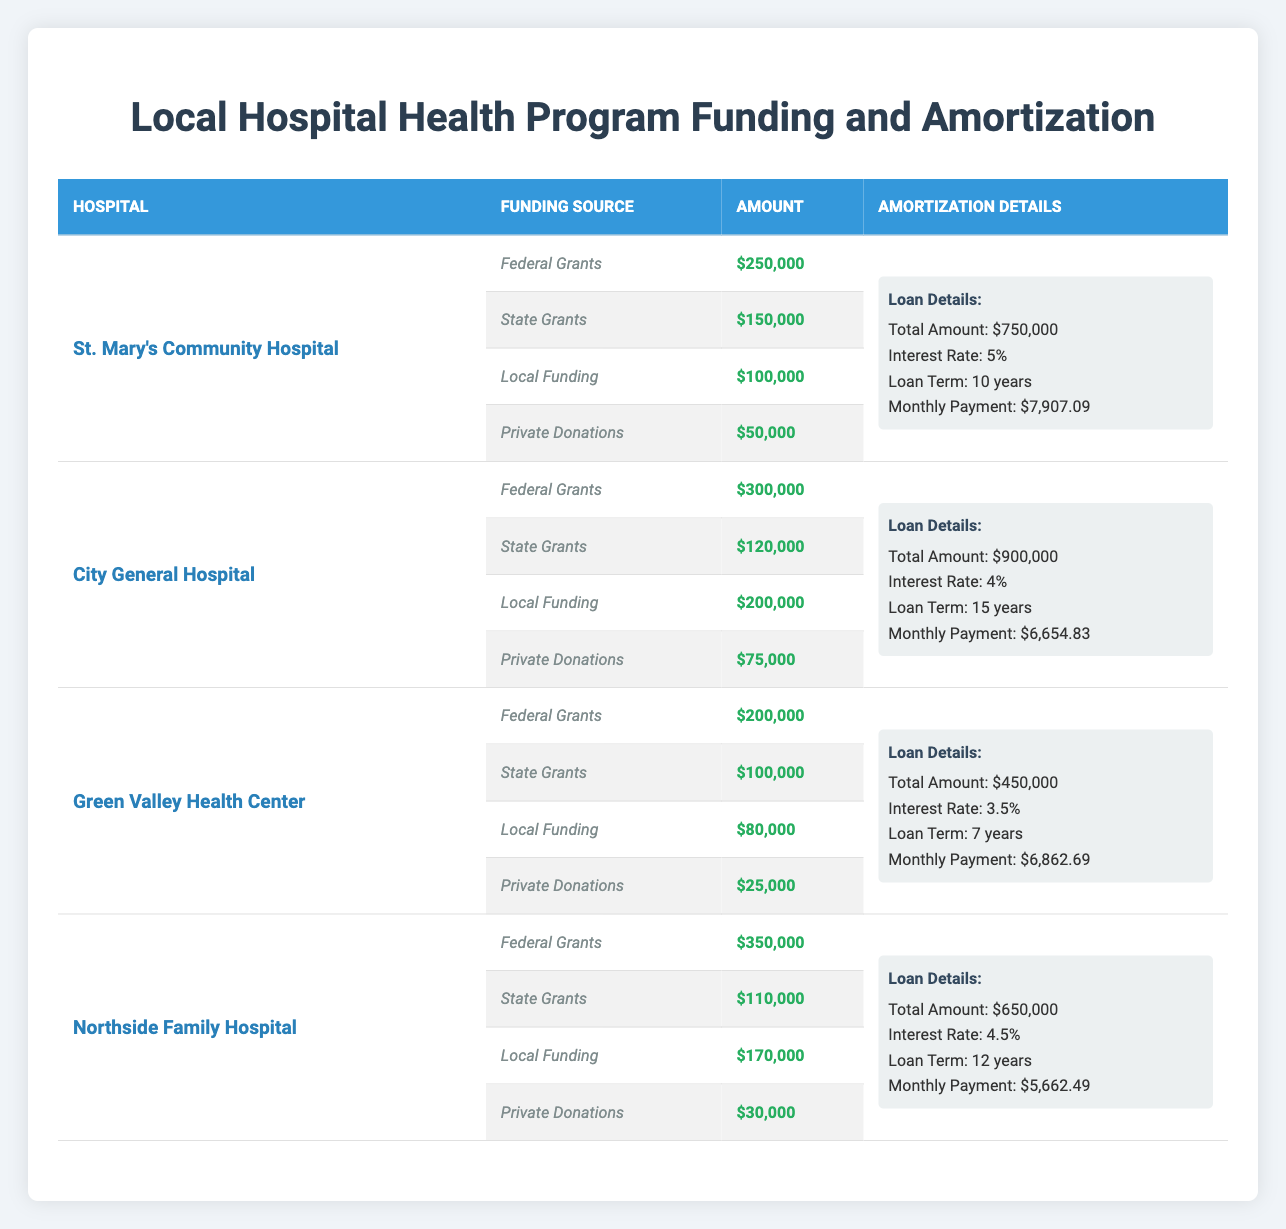What is the total amount of funding received by City General Hospital? The funding sources for City General Hospital are: Federal Grants ($300,000), State Grants ($120,000), Local Funding ($200,000), and Private Donations ($75,000). Adding these amounts together gives: 300,000 + 120,000 + 200,000 + 75,000 = 695,000.
Answer: 695,000 Which hospital has the highest monthly payment for amortization? Looking at the monthly payments for each hospital: St. Mary’s Community Hospital ($7,907.09), City General Hospital ($6,654.83), Green Valley Health Center ($6,862.69), and Northside Family Hospital ($5,662.49). Comparing these values shows that St. Mary’s Community Hospital has the highest monthly payment.
Answer: St. Mary’s Community Hospital What is the total amount of federal grants received by all hospitals combined? The federal grants for each hospital are: St. Mary’s Community Hospital ($250,000), City General Hospital ($300,000), Green Valley Health Center ($200,000), and Northside Family Hospital ($350,000). Adding these gives: 250,000 + 300,000 + 200,000 + 350,000 = 1,100,000.
Answer: 1,100,000 Does Green Valley Health Center have a lower interest rate than Northside Family Hospital? The interest rates for Green Valley Health Center and Northside Family Hospital are 3.5% and 4.5% respectively. Since 3.5% is less than 4.5%, the answer is yes.
Answer: Yes What is the average local funding across all hospitals? The local funding amounts are: St. Mary’s Community Hospital ($100,000), City General Hospital ($200,000), Green Valley Health Center ($80,000), and Northside Family Hospital ($170,000). First, we sum these amounts: 100,000 + 200,000 + 80,000 + 170,000 = 550,000. Then we divide by the number of hospitals (4) to find the average: 550,000 / 4 = 137,500.
Answer: 137,500 What proportion of funding comes from private donations for Northside Family Hospital? The total funding for Northside Family Hospital is made up of: Federal Grants ($350,000), State Grants ($110,000), Local Funding ($170,000), and Private Donations ($30,000). The total funding is: 350,000 + 110,000 + 170,000 + 30,000 = 660,000. The private donations are $30,000. So the proportion is: 30,000 / 660,000 ≈ 0.0455, or about 4.55%.
Answer: Approximately 4.55% Which hospital received the least amount in federal grants? The federal grant amounts for each hospital are: St. Mary’s ($250,000), City General ($300,000), Green Valley ($200,000), and Northside ($350,000). Comparing these, Green Valley Health Center received the least, with $200,000.
Answer: Green Valley Health Center What is the total amortization amount for hospitals with an interest rate of 4% or lower? The total amortization amounts for relevant hospitals are: City General Hospital ($900,000), Green Valley Health Center ($450,000), and Northside Family Hospital ($650,000). Summing these gives: 900,000 + 450,000 + 650,000 = 2,000,000.
Answer: 2,000,000 